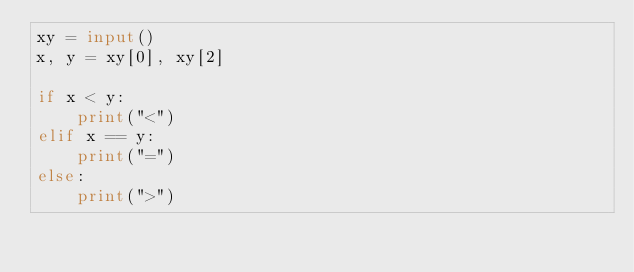Convert code to text. <code><loc_0><loc_0><loc_500><loc_500><_Python_>xy = input()
x, y = xy[0], xy[2]

if x < y:
    print("<")
elif x == y:
    print("=")
else:
    print(">")</code> 